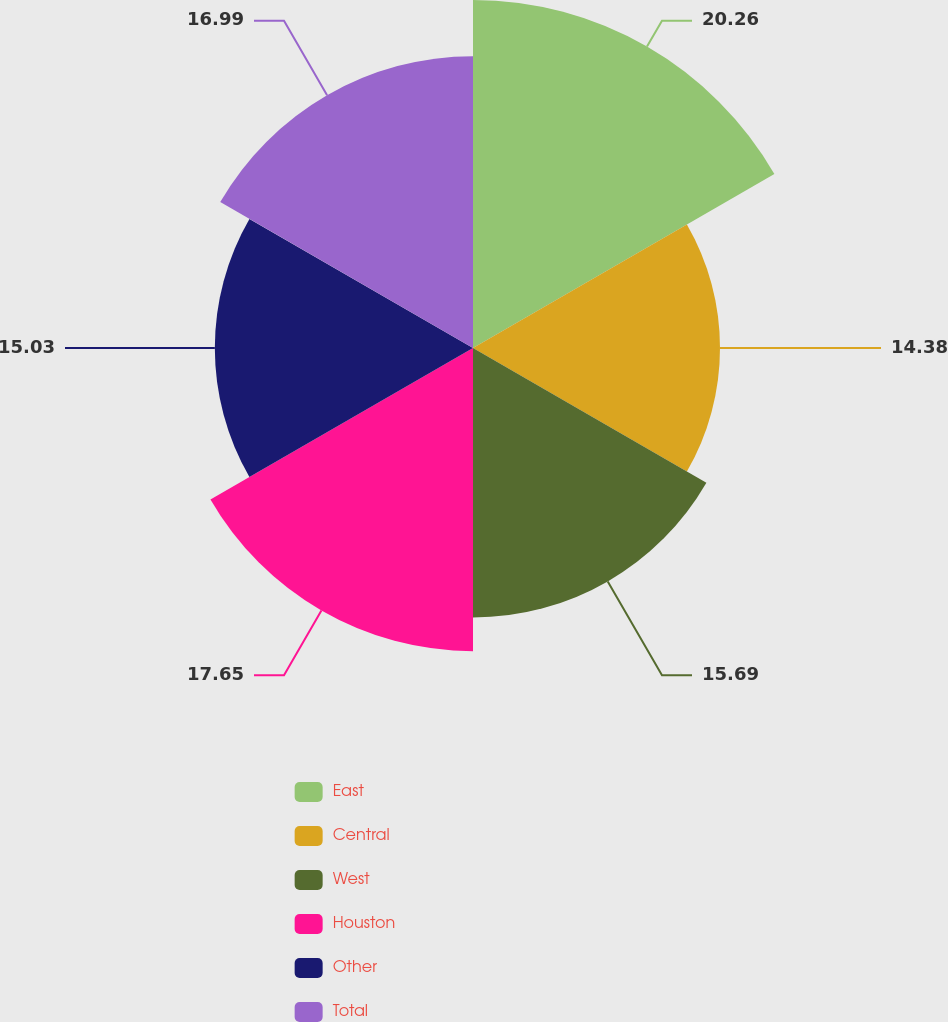Convert chart to OTSL. <chart><loc_0><loc_0><loc_500><loc_500><pie_chart><fcel>East<fcel>Central<fcel>West<fcel>Houston<fcel>Other<fcel>Total<nl><fcel>20.26%<fcel>14.38%<fcel>15.69%<fcel>17.65%<fcel>15.03%<fcel>16.99%<nl></chart> 